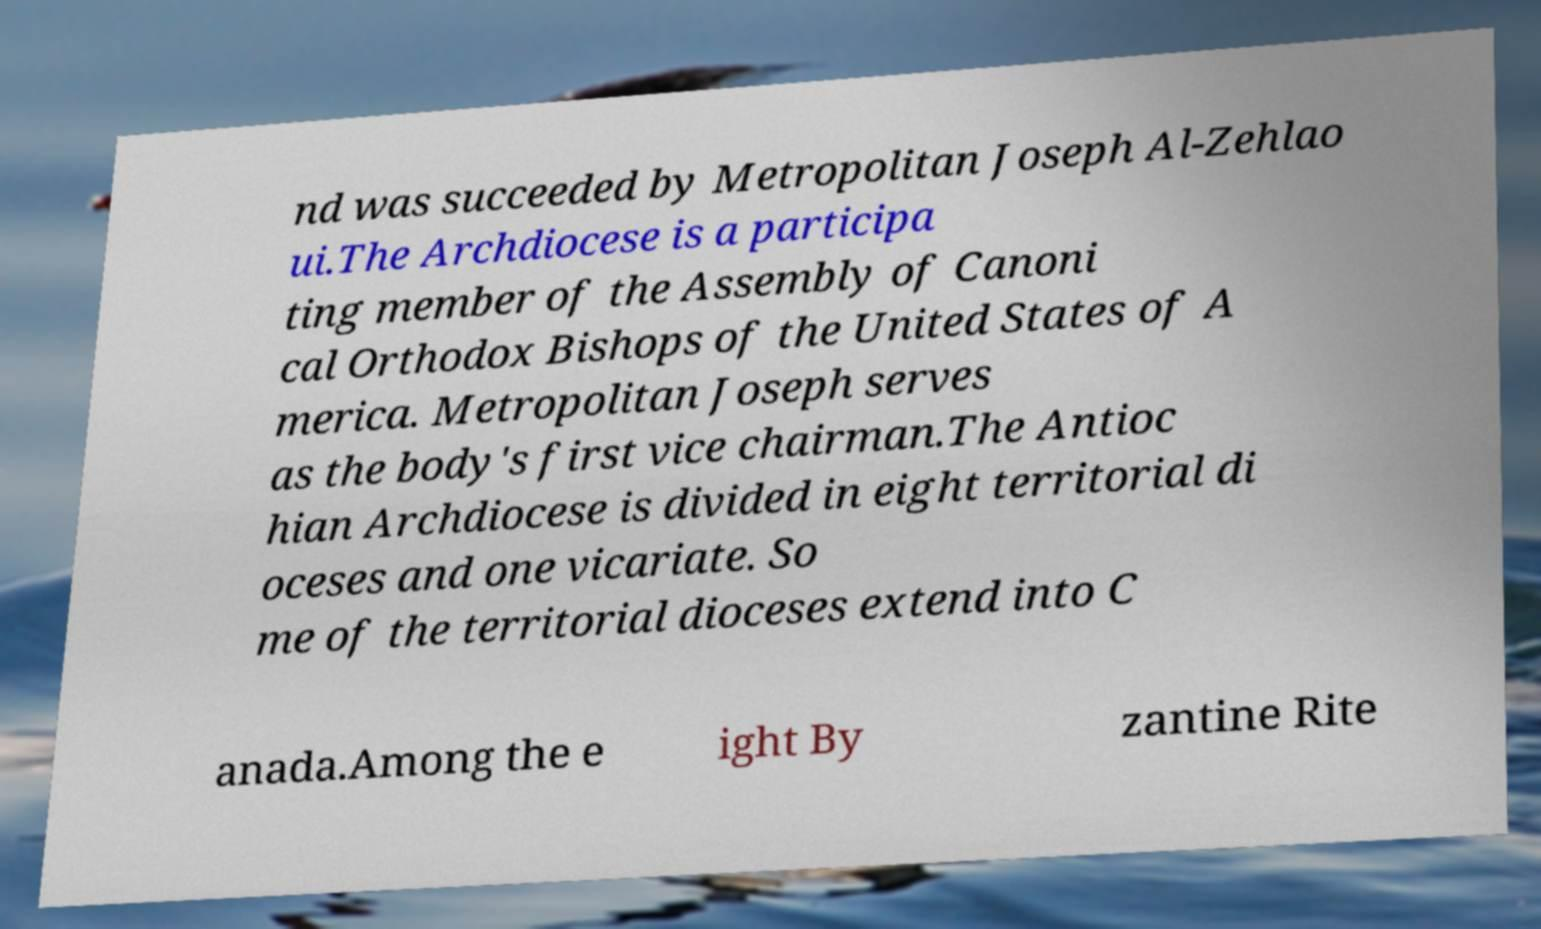Can you accurately transcribe the text from the provided image for me? nd was succeeded by Metropolitan Joseph Al-Zehlao ui.The Archdiocese is a participa ting member of the Assembly of Canoni cal Orthodox Bishops of the United States of A merica. Metropolitan Joseph serves as the body's first vice chairman.The Antioc hian Archdiocese is divided in eight territorial di oceses and one vicariate. So me of the territorial dioceses extend into C anada.Among the e ight By zantine Rite 